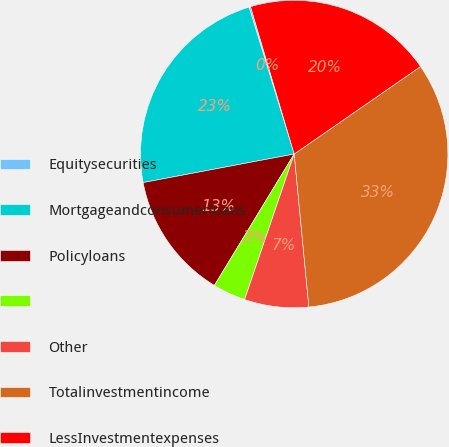Convert chart. <chart><loc_0><loc_0><loc_500><loc_500><pie_chart><fcel>Equitysecurities<fcel>Mortgageandconsumerloans<fcel>Policyloans<fcel>Unnamed: 3<fcel>Other<fcel>Totalinvestmentincome<fcel>LessInvestmentexpenses<nl><fcel>0.16%<fcel>23.23%<fcel>13.34%<fcel>3.46%<fcel>6.75%<fcel>33.12%<fcel>19.94%<nl></chart> 